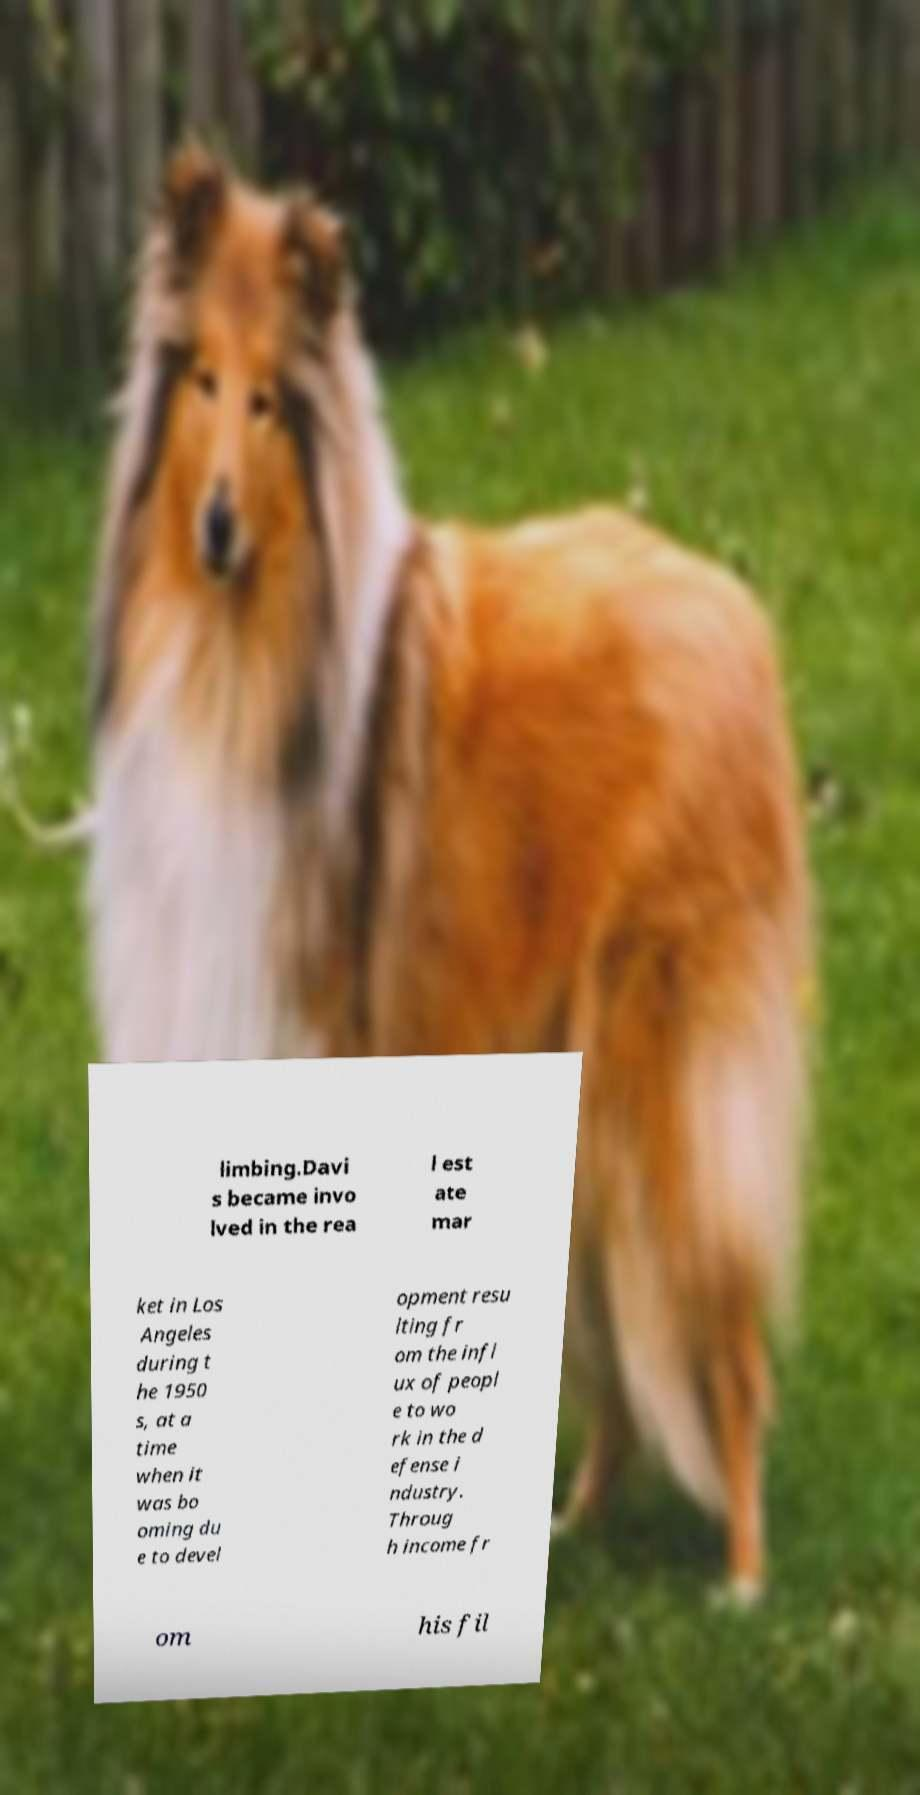There's text embedded in this image that I need extracted. Can you transcribe it verbatim? limbing.Davi s became invo lved in the rea l est ate mar ket in Los Angeles during t he 1950 s, at a time when it was bo oming du e to devel opment resu lting fr om the infl ux of peopl e to wo rk in the d efense i ndustry. Throug h income fr om his fil 